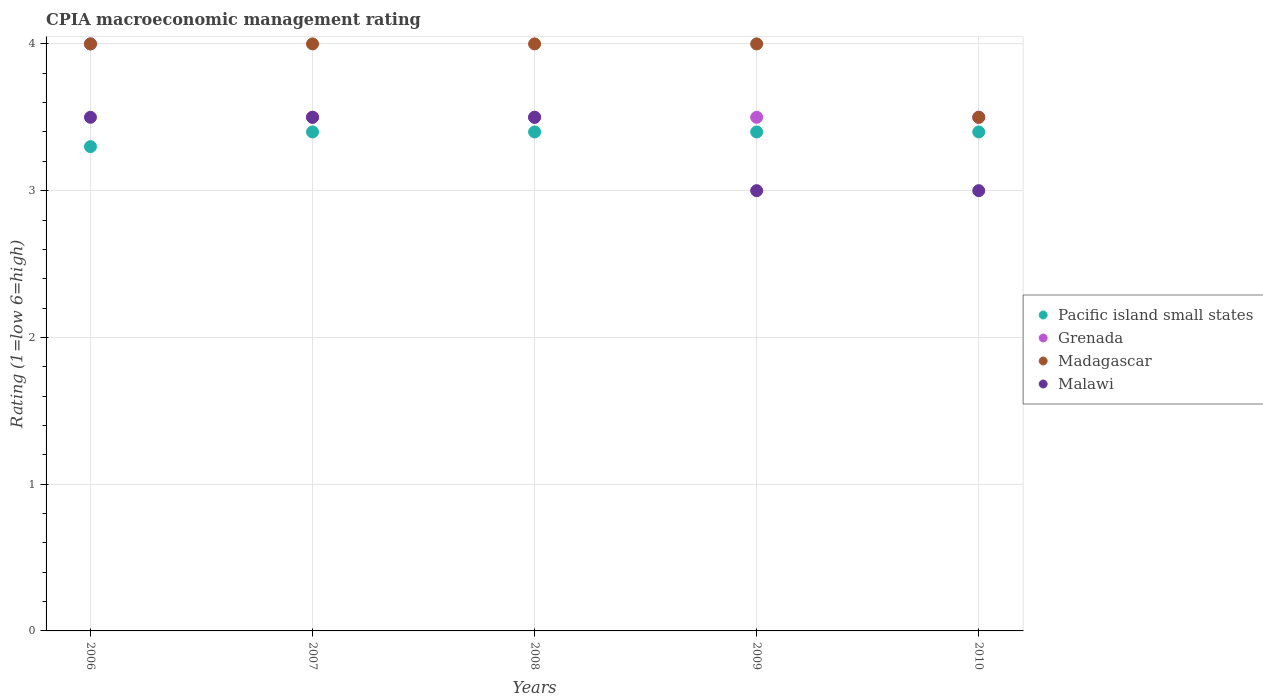Is the number of dotlines equal to the number of legend labels?
Your response must be concise. Yes. In which year was the CPIA rating in Madagascar maximum?
Offer a very short reply. 2006. In which year was the CPIA rating in Malawi minimum?
Keep it short and to the point. 2009. What is the difference between the CPIA rating in Malawi in 2006 and that in 2010?
Provide a succinct answer. 0.5. What is the difference between the CPIA rating in Grenada in 2008 and the CPIA rating in Malawi in 2007?
Keep it short and to the point. 0. What is the average CPIA rating in Grenada per year?
Offer a terse response. 3.6. In how many years, is the CPIA rating in Pacific island small states greater than 0.2?
Provide a short and direct response. 5. What is the difference between the highest and the second highest CPIA rating in Grenada?
Provide a short and direct response. 0.5. What is the difference between the highest and the lowest CPIA rating in Madagascar?
Make the answer very short. 0.5. In how many years, is the CPIA rating in Grenada greater than the average CPIA rating in Grenada taken over all years?
Your response must be concise. 1. Is it the case that in every year, the sum of the CPIA rating in Grenada and CPIA rating in Pacific island small states  is greater than the sum of CPIA rating in Malawi and CPIA rating in Madagascar?
Provide a short and direct response. No. Is the CPIA rating in Madagascar strictly less than the CPIA rating in Pacific island small states over the years?
Ensure brevity in your answer.  No. How many years are there in the graph?
Ensure brevity in your answer.  5. What is the difference between two consecutive major ticks on the Y-axis?
Your response must be concise. 1. Are the values on the major ticks of Y-axis written in scientific E-notation?
Offer a very short reply. No. Does the graph contain grids?
Your answer should be very brief. Yes. How are the legend labels stacked?
Your answer should be compact. Vertical. What is the title of the graph?
Give a very brief answer. CPIA macroeconomic management rating. Does "Sri Lanka" appear as one of the legend labels in the graph?
Provide a succinct answer. No. What is the label or title of the X-axis?
Provide a short and direct response. Years. What is the label or title of the Y-axis?
Make the answer very short. Rating (1=low 6=high). What is the Rating (1=low 6=high) in Pacific island small states in 2006?
Your answer should be compact. 3.3. What is the Rating (1=low 6=high) in Madagascar in 2006?
Give a very brief answer. 4. What is the Rating (1=low 6=high) in Malawi in 2006?
Offer a very short reply. 3.5. What is the Rating (1=low 6=high) of Madagascar in 2007?
Make the answer very short. 4. What is the Rating (1=low 6=high) in Malawi in 2008?
Your response must be concise. 3.5. What is the Rating (1=low 6=high) of Pacific island small states in 2009?
Ensure brevity in your answer.  3.4. What is the Rating (1=low 6=high) in Madagascar in 2009?
Ensure brevity in your answer.  4. What is the Rating (1=low 6=high) of Malawi in 2009?
Make the answer very short. 3. What is the Rating (1=low 6=high) of Pacific island small states in 2010?
Give a very brief answer. 3.4. What is the Rating (1=low 6=high) in Grenada in 2010?
Your answer should be very brief. 3.5. What is the Rating (1=low 6=high) of Malawi in 2010?
Offer a terse response. 3. Across all years, what is the maximum Rating (1=low 6=high) of Pacific island small states?
Provide a succinct answer. 3.4. Across all years, what is the minimum Rating (1=low 6=high) of Grenada?
Ensure brevity in your answer.  3.5. What is the total Rating (1=low 6=high) in Pacific island small states in the graph?
Your response must be concise. 16.9. What is the total Rating (1=low 6=high) in Madagascar in the graph?
Your response must be concise. 19.5. What is the total Rating (1=low 6=high) in Malawi in the graph?
Ensure brevity in your answer.  16.5. What is the difference between the Rating (1=low 6=high) of Pacific island small states in 2006 and that in 2007?
Give a very brief answer. -0.1. What is the difference between the Rating (1=low 6=high) in Grenada in 2006 and that in 2007?
Give a very brief answer. 0.5. What is the difference between the Rating (1=low 6=high) of Malawi in 2006 and that in 2007?
Your answer should be compact. 0. What is the difference between the Rating (1=low 6=high) of Pacific island small states in 2006 and that in 2008?
Give a very brief answer. -0.1. What is the difference between the Rating (1=low 6=high) of Grenada in 2006 and that in 2008?
Offer a terse response. 0.5. What is the difference between the Rating (1=low 6=high) in Madagascar in 2006 and that in 2008?
Provide a short and direct response. 0. What is the difference between the Rating (1=low 6=high) of Malawi in 2006 and that in 2008?
Your answer should be compact. 0. What is the difference between the Rating (1=low 6=high) in Grenada in 2006 and that in 2009?
Make the answer very short. 0.5. What is the difference between the Rating (1=low 6=high) in Madagascar in 2006 and that in 2009?
Make the answer very short. 0. What is the difference between the Rating (1=low 6=high) of Pacific island small states in 2006 and that in 2010?
Offer a very short reply. -0.1. What is the difference between the Rating (1=low 6=high) in Madagascar in 2006 and that in 2010?
Your answer should be compact. 0.5. What is the difference between the Rating (1=low 6=high) of Malawi in 2006 and that in 2010?
Your response must be concise. 0.5. What is the difference between the Rating (1=low 6=high) in Madagascar in 2007 and that in 2008?
Keep it short and to the point. 0. What is the difference between the Rating (1=low 6=high) of Malawi in 2007 and that in 2008?
Your response must be concise. 0. What is the difference between the Rating (1=low 6=high) of Pacific island small states in 2007 and that in 2009?
Give a very brief answer. 0. What is the difference between the Rating (1=low 6=high) in Madagascar in 2007 and that in 2009?
Make the answer very short. 0. What is the difference between the Rating (1=low 6=high) in Malawi in 2007 and that in 2009?
Your answer should be very brief. 0.5. What is the difference between the Rating (1=low 6=high) of Pacific island small states in 2007 and that in 2010?
Ensure brevity in your answer.  0. What is the difference between the Rating (1=low 6=high) in Grenada in 2008 and that in 2009?
Provide a short and direct response. 0. What is the difference between the Rating (1=low 6=high) of Madagascar in 2008 and that in 2009?
Provide a short and direct response. 0. What is the difference between the Rating (1=low 6=high) of Grenada in 2009 and that in 2010?
Your answer should be very brief. 0. What is the difference between the Rating (1=low 6=high) of Madagascar in 2009 and that in 2010?
Provide a short and direct response. 0.5. What is the difference between the Rating (1=low 6=high) of Malawi in 2009 and that in 2010?
Make the answer very short. 0. What is the difference between the Rating (1=low 6=high) in Pacific island small states in 2006 and the Rating (1=low 6=high) in Grenada in 2007?
Ensure brevity in your answer.  -0.2. What is the difference between the Rating (1=low 6=high) of Pacific island small states in 2006 and the Rating (1=low 6=high) of Malawi in 2007?
Provide a short and direct response. -0.2. What is the difference between the Rating (1=low 6=high) in Grenada in 2006 and the Rating (1=low 6=high) in Madagascar in 2007?
Your answer should be very brief. 0. What is the difference between the Rating (1=low 6=high) in Grenada in 2006 and the Rating (1=low 6=high) in Malawi in 2007?
Provide a short and direct response. 0.5. What is the difference between the Rating (1=low 6=high) of Pacific island small states in 2006 and the Rating (1=low 6=high) of Grenada in 2008?
Provide a succinct answer. -0.2. What is the difference between the Rating (1=low 6=high) in Pacific island small states in 2006 and the Rating (1=low 6=high) in Malawi in 2008?
Give a very brief answer. -0.2. What is the difference between the Rating (1=low 6=high) of Grenada in 2006 and the Rating (1=low 6=high) of Madagascar in 2008?
Give a very brief answer. 0. What is the difference between the Rating (1=low 6=high) in Pacific island small states in 2006 and the Rating (1=low 6=high) in Grenada in 2009?
Provide a succinct answer. -0.2. What is the difference between the Rating (1=low 6=high) in Pacific island small states in 2006 and the Rating (1=low 6=high) in Malawi in 2009?
Ensure brevity in your answer.  0.3. What is the difference between the Rating (1=low 6=high) of Madagascar in 2006 and the Rating (1=low 6=high) of Malawi in 2009?
Make the answer very short. 1. What is the difference between the Rating (1=low 6=high) of Pacific island small states in 2006 and the Rating (1=low 6=high) of Malawi in 2010?
Provide a short and direct response. 0.3. What is the difference between the Rating (1=low 6=high) of Grenada in 2006 and the Rating (1=low 6=high) of Malawi in 2010?
Offer a terse response. 1. What is the difference between the Rating (1=low 6=high) of Madagascar in 2006 and the Rating (1=low 6=high) of Malawi in 2010?
Your answer should be compact. 1. What is the difference between the Rating (1=low 6=high) in Pacific island small states in 2007 and the Rating (1=low 6=high) in Madagascar in 2008?
Provide a succinct answer. -0.6. What is the difference between the Rating (1=low 6=high) of Pacific island small states in 2007 and the Rating (1=low 6=high) of Malawi in 2008?
Ensure brevity in your answer.  -0.1. What is the difference between the Rating (1=low 6=high) in Madagascar in 2007 and the Rating (1=low 6=high) in Malawi in 2008?
Your response must be concise. 0.5. What is the difference between the Rating (1=low 6=high) in Grenada in 2007 and the Rating (1=low 6=high) in Madagascar in 2009?
Provide a short and direct response. -0.5. What is the difference between the Rating (1=low 6=high) in Grenada in 2007 and the Rating (1=low 6=high) in Malawi in 2009?
Offer a terse response. 0.5. What is the difference between the Rating (1=low 6=high) in Madagascar in 2007 and the Rating (1=low 6=high) in Malawi in 2009?
Make the answer very short. 1. What is the difference between the Rating (1=low 6=high) of Pacific island small states in 2007 and the Rating (1=low 6=high) of Madagascar in 2010?
Offer a terse response. -0.1. What is the difference between the Rating (1=low 6=high) of Pacific island small states in 2007 and the Rating (1=low 6=high) of Malawi in 2010?
Ensure brevity in your answer.  0.4. What is the difference between the Rating (1=low 6=high) of Pacific island small states in 2008 and the Rating (1=low 6=high) of Grenada in 2009?
Your answer should be very brief. -0.1. What is the difference between the Rating (1=low 6=high) in Grenada in 2008 and the Rating (1=low 6=high) in Madagascar in 2009?
Give a very brief answer. -0.5. What is the difference between the Rating (1=low 6=high) of Madagascar in 2008 and the Rating (1=low 6=high) of Malawi in 2009?
Your answer should be very brief. 1. What is the difference between the Rating (1=low 6=high) in Pacific island small states in 2008 and the Rating (1=low 6=high) in Madagascar in 2010?
Give a very brief answer. -0.1. What is the difference between the Rating (1=low 6=high) of Pacific island small states in 2008 and the Rating (1=low 6=high) of Malawi in 2010?
Ensure brevity in your answer.  0.4. What is the difference between the Rating (1=low 6=high) of Grenada in 2008 and the Rating (1=low 6=high) of Madagascar in 2010?
Give a very brief answer. 0. What is the difference between the Rating (1=low 6=high) of Grenada in 2008 and the Rating (1=low 6=high) of Malawi in 2010?
Give a very brief answer. 0.5. What is the difference between the Rating (1=low 6=high) of Madagascar in 2008 and the Rating (1=low 6=high) of Malawi in 2010?
Keep it short and to the point. 1. What is the difference between the Rating (1=low 6=high) of Pacific island small states in 2009 and the Rating (1=low 6=high) of Grenada in 2010?
Keep it short and to the point. -0.1. What is the difference between the Rating (1=low 6=high) in Pacific island small states in 2009 and the Rating (1=low 6=high) in Madagascar in 2010?
Make the answer very short. -0.1. What is the difference between the Rating (1=low 6=high) in Grenada in 2009 and the Rating (1=low 6=high) in Malawi in 2010?
Offer a terse response. 0.5. What is the average Rating (1=low 6=high) of Pacific island small states per year?
Give a very brief answer. 3.38. In the year 2006, what is the difference between the Rating (1=low 6=high) of Pacific island small states and Rating (1=low 6=high) of Grenada?
Give a very brief answer. -0.7. In the year 2006, what is the difference between the Rating (1=low 6=high) in Pacific island small states and Rating (1=low 6=high) in Madagascar?
Ensure brevity in your answer.  -0.7. In the year 2006, what is the difference between the Rating (1=low 6=high) in Grenada and Rating (1=low 6=high) in Malawi?
Ensure brevity in your answer.  0.5. In the year 2007, what is the difference between the Rating (1=low 6=high) of Pacific island small states and Rating (1=low 6=high) of Madagascar?
Your answer should be very brief. -0.6. In the year 2007, what is the difference between the Rating (1=low 6=high) of Pacific island small states and Rating (1=low 6=high) of Malawi?
Ensure brevity in your answer.  -0.1. In the year 2007, what is the difference between the Rating (1=low 6=high) of Grenada and Rating (1=low 6=high) of Madagascar?
Make the answer very short. -0.5. In the year 2007, what is the difference between the Rating (1=low 6=high) of Grenada and Rating (1=low 6=high) of Malawi?
Offer a terse response. 0. In the year 2007, what is the difference between the Rating (1=low 6=high) of Madagascar and Rating (1=low 6=high) of Malawi?
Provide a succinct answer. 0.5. In the year 2008, what is the difference between the Rating (1=low 6=high) in Pacific island small states and Rating (1=low 6=high) in Madagascar?
Make the answer very short. -0.6. In the year 2008, what is the difference between the Rating (1=low 6=high) in Pacific island small states and Rating (1=low 6=high) in Malawi?
Offer a terse response. -0.1. In the year 2008, what is the difference between the Rating (1=low 6=high) of Grenada and Rating (1=low 6=high) of Madagascar?
Your answer should be very brief. -0.5. In the year 2008, what is the difference between the Rating (1=low 6=high) in Grenada and Rating (1=low 6=high) in Malawi?
Keep it short and to the point. 0. In the year 2009, what is the difference between the Rating (1=low 6=high) of Pacific island small states and Rating (1=low 6=high) of Grenada?
Offer a very short reply. -0.1. In the year 2009, what is the difference between the Rating (1=low 6=high) of Pacific island small states and Rating (1=low 6=high) of Madagascar?
Make the answer very short. -0.6. In the year 2009, what is the difference between the Rating (1=low 6=high) of Madagascar and Rating (1=low 6=high) of Malawi?
Offer a terse response. 1. In the year 2010, what is the difference between the Rating (1=low 6=high) of Pacific island small states and Rating (1=low 6=high) of Madagascar?
Provide a short and direct response. -0.1. In the year 2010, what is the difference between the Rating (1=low 6=high) in Madagascar and Rating (1=low 6=high) in Malawi?
Keep it short and to the point. 0.5. What is the ratio of the Rating (1=low 6=high) of Pacific island small states in 2006 to that in 2007?
Make the answer very short. 0.97. What is the ratio of the Rating (1=low 6=high) in Grenada in 2006 to that in 2007?
Ensure brevity in your answer.  1.14. What is the ratio of the Rating (1=low 6=high) of Pacific island small states in 2006 to that in 2008?
Make the answer very short. 0.97. What is the ratio of the Rating (1=low 6=high) in Madagascar in 2006 to that in 2008?
Ensure brevity in your answer.  1. What is the ratio of the Rating (1=low 6=high) of Malawi in 2006 to that in 2008?
Your answer should be very brief. 1. What is the ratio of the Rating (1=low 6=high) of Pacific island small states in 2006 to that in 2009?
Keep it short and to the point. 0.97. What is the ratio of the Rating (1=low 6=high) in Grenada in 2006 to that in 2009?
Your answer should be very brief. 1.14. What is the ratio of the Rating (1=low 6=high) in Malawi in 2006 to that in 2009?
Make the answer very short. 1.17. What is the ratio of the Rating (1=low 6=high) of Pacific island small states in 2006 to that in 2010?
Make the answer very short. 0.97. What is the ratio of the Rating (1=low 6=high) of Grenada in 2007 to that in 2008?
Keep it short and to the point. 1. What is the ratio of the Rating (1=low 6=high) in Madagascar in 2007 to that in 2008?
Make the answer very short. 1. What is the ratio of the Rating (1=low 6=high) of Malawi in 2007 to that in 2008?
Ensure brevity in your answer.  1. What is the ratio of the Rating (1=low 6=high) of Grenada in 2007 to that in 2009?
Your response must be concise. 1. What is the ratio of the Rating (1=low 6=high) in Madagascar in 2007 to that in 2009?
Your answer should be very brief. 1. What is the ratio of the Rating (1=low 6=high) of Malawi in 2007 to that in 2009?
Give a very brief answer. 1.17. What is the ratio of the Rating (1=low 6=high) of Pacific island small states in 2007 to that in 2010?
Give a very brief answer. 1. What is the ratio of the Rating (1=low 6=high) in Madagascar in 2007 to that in 2010?
Your answer should be compact. 1.14. What is the ratio of the Rating (1=low 6=high) of Pacific island small states in 2008 to that in 2009?
Your answer should be very brief. 1. What is the ratio of the Rating (1=low 6=high) of Grenada in 2008 to that in 2009?
Ensure brevity in your answer.  1. What is the ratio of the Rating (1=low 6=high) of Pacific island small states in 2008 to that in 2010?
Your answer should be very brief. 1. What is the ratio of the Rating (1=low 6=high) of Grenada in 2008 to that in 2010?
Ensure brevity in your answer.  1. What is the ratio of the Rating (1=low 6=high) in Malawi in 2008 to that in 2010?
Provide a short and direct response. 1.17. What is the ratio of the Rating (1=low 6=high) of Malawi in 2009 to that in 2010?
Provide a succinct answer. 1. What is the difference between the highest and the second highest Rating (1=low 6=high) in Pacific island small states?
Make the answer very short. 0. What is the difference between the highest and the second highest Rating (1=low 6=high) in Grenada?
Make the answer very short. 0.5. What is the difference between the highest and the second highest Rating (1=low 6=high) of Madagascar?
Give a very brief answer. 0. What is the difference between the highest and the second highest Rating (1=low 6=high) in Malawi?
Ensure brevity in your answer.  0. What is the difference between the highest and the lowest Rating (1=low 6=high) of Grenada?
Keep it short and to the point. 0.5. 